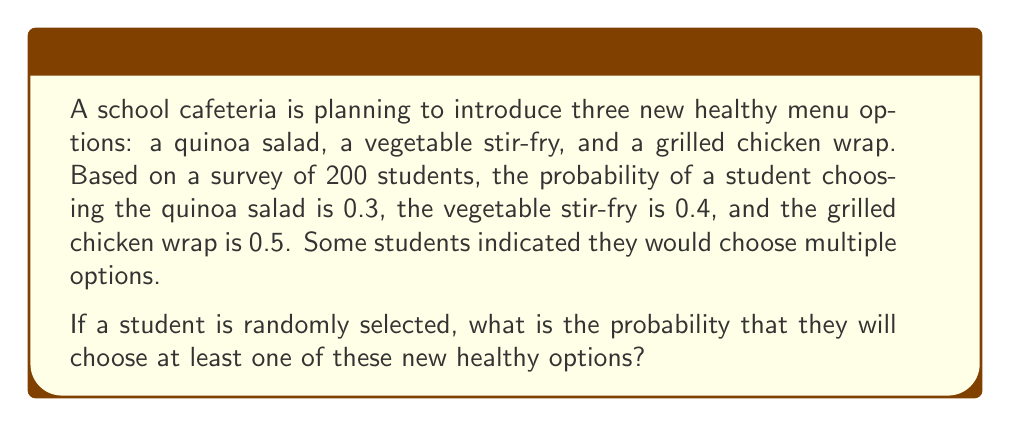What is the answer to this math problem? To solve this problem, we can use the principle of inclusion-exclusion from probability theory. Let's define our events:

$A$: Student chooses quinoa salad
$B$: Student chooses vegetable stir-fry
$C$: Student chooses grilled chicken wrap

We're given:
$P(A) = 0.3$
$P(B) = 0.4$
$P(C) = 0.5$

We want to find $P(A \cup B \cup C)$, the probability of choosing at least one option.

The principle of inclusion-exclusion states:

$$P(A \cup B \cup C) = P(A) + P(B) + P(C) - P(A \cap B) - P(A \cap C) - P(B \cap C) + P(A \cap B \cap C)$$

However, we don't know the probabilities of the intersections. In this case, we can use the complement of the probability we're looking for:

$$P(A \cup B \cup C) = 1 - P(\overline{A} \cap \overline{B} \cap \overline{C})$$

Where $\overline{A}$, $\overline{B}$, and $\overline{C}$ represent not choosing each option.

Assuming independence (which is a reasonable assumption given the information provided):

$$P(\overline{A} \cap \overline{B} \cap \overline{C}) = P(\overline{A}) \cdot P(\overline{B}) \cdot P(\overline{C})$$

$$= (1 - P(A)) \cdot (1 - P(B)) \cdot (1 - P(C))$$
$$= (1 - 0.3) \cdot (1 - 0.4) \cdot (1 - 0.5)$$
$$= 0.7 \cdot 0.6 \cdot 0.5$$
$$= 0.21$$

Therefore, the probability of choosing at least one new healthy option is:

$$P(A \cup B \cup C) = 1 - 0.21 = 0.79$$
Answer: The probability that a randomly selected student will choose at least one of the new healthy options is 0.79 or 79%. 